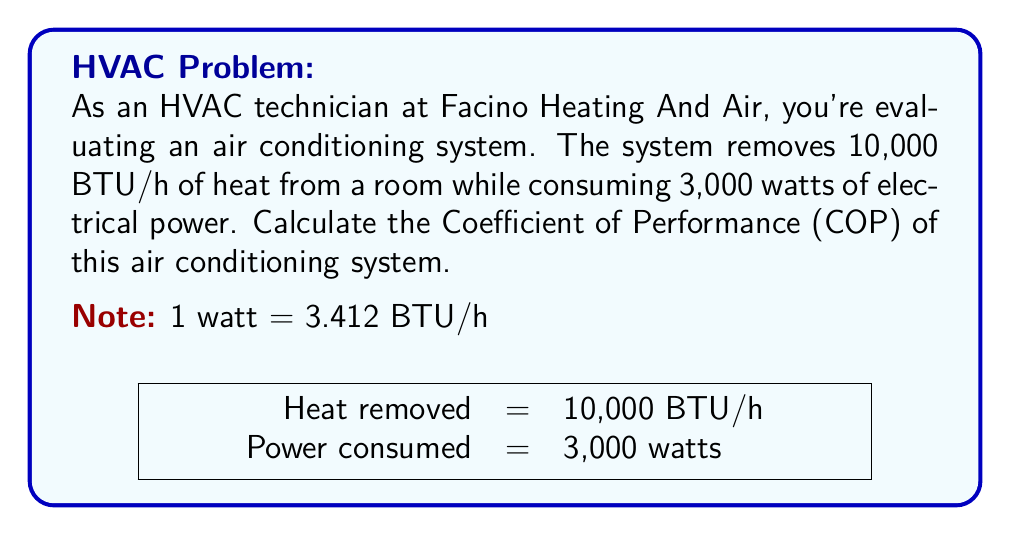Help me with this question. To determine the efficiency of an air conditioning system using the Coefficient of Performance (COP), we follow these steps:

1) The COP is defined as:

   $$ COP = \frac{\text{Cooling Effect}}{\text{Work Input}} $$

2) We're given:
   - Cooling Effect = 10,000 BTU/h
   - Work Input = 3,000 watts

3) We need to convert the Work Input to BTU/h:
   $$ 3,000 \text{ watts} \times \frac{3.412 \text{ BTU/h}}{1 \text{ watt}} = 10,236 \text{ BTU/h} $$

4) Now we can calculate the COP:

   $$ COP = \frac{10,000 \text{ BTU/h}}{10,236 \text{ BTU/h}} $$

5) Simplifying:
   $$ COP = 0.9769 $$

6) Rounding to two decimal places:
   $$ COP = 0.98 $$

This means that for every unit of energy input, the air conditioning system removes 0.98 units of heat from the room.
Answer: 0.98 